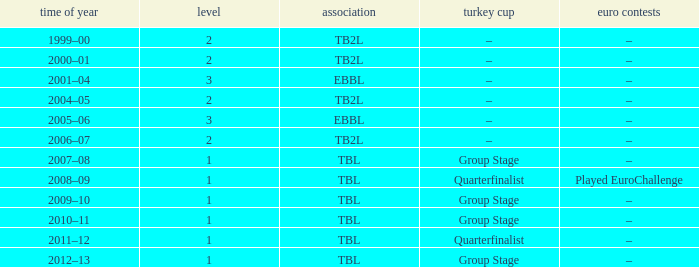Tier of 2, and a Season of 2000–01 is what European competitions? –. 